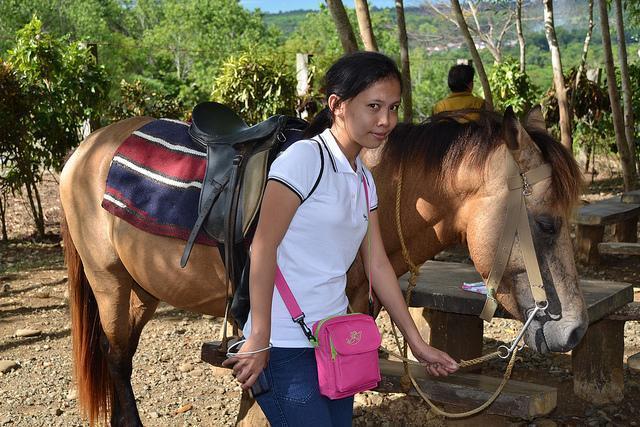How many people can you see?
Give a very brief answer. 2. How many benches can you see?
Give a very brief answer. 2. 